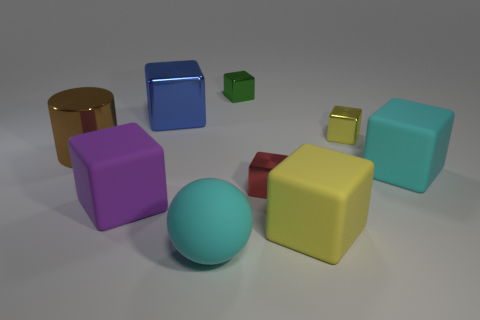Subtract 3 cubes. How many cubes are left? 4 Subtract all big yellow blocks. How many blocks are left? 6 Subtract all blue blocks. How many blocks are left? 6 Subtract all green cubes. Subtract all brown spheres. How many cubes are left? 6 Add 1 large yellow rubber blocks. How many objects exist? 10 Subtract all cylinders. How many objects are left? 8 Subtract all large purple cubes. Subtract all large yellow cubes. How many objects are left? 7 Add 9 tiny red cubes. How many tiny red cubes are left? 10 Add 7 big cyan balls. How many big cyan balls exist? 8 Subtract 0 gray blocks. How many objects are left? 9 